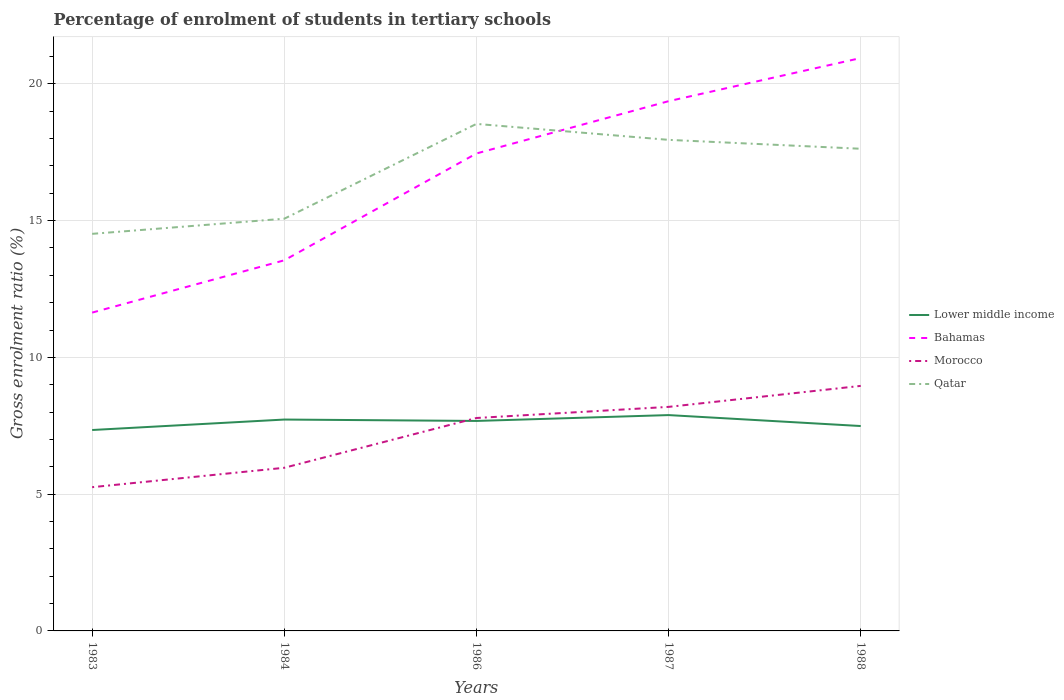How many different coloured lines are there?
Offer a very short reply. 4. Does the line corresponding to Lower middle income intersect with the line corresponding to Bahamas?
Your answer should be compact. No. Is the number of lines equal to the number of legend labels?
Ensure brevity in your answer.  Yes. Across all years, what is the maximum percentage of students enrolled in tertiary schools in Morocco?
Make the answer very short. 5.25. In which year was the percentage of students enrolled in tertiary schools in Morocco maximum?
Give a very brief answer. 1983. What is the total percentage of students enrolled in tertiary schools in Bahamas in the graph?
Your answer should be compact. -5.82. What is the difference between the highest and the second highest percentage of students enrolled in tertiary schools in Morocco?
Offer a very short reply. 3.7. What is the difference between the highest and the lowest percentage of students enrolled in tertiary schools in Lower middle income?
Keep it short and to the point. 3. Is the percentage of students enrolled in tertiary schools in Lower middle income strictly greater than the percentage of students enrolled in tertiary schools in Bahamas over the years?
Your response must be concise. Yes. How many lines are there?
Ensure brevity in your answer.  4. How many years are there in the graph?
Ensure brevity in your answer.  5. Are the values on the major ticks of Y-axis written in scientific E-notation?
Offer a terse response. No. Does the graph contain any zero values?
Offer a terse response. No. How many legend labels are there?
Your answer should be very brief. 4. What is the title of the graph?
Your response must be concise. Percentage of enrolment of students in tertiary schools. What is the label or title of the X-axis?
Keep it short and to the point. Years. What is the label or title of the Y-axis?
Give a very brief answer. Gross enrolment ratio (%). What is the Gross enrolment ratio (%) in Lower middle income in 1983?
Ensure brevity in your answer.  7.34. What is the Gross enrolment ratio (%) of Bahamas in 1983?
Provide a short and direct response. 11.64. What is the Gross enrolment ratio (%) in Morocco in 1983?
Provide a short and direct response. 5.25. What is the Gross enrolment ratio (%) of Qatar in 1983?
Make the answer very short. 14.52. What is the Gross enrolment ratio (%) of Lower middle income in 1984?
Make the answer very short. 7.73. What is the Gross enrolment ratio (%) of Bahamas in 1984?
Ensure brevity in your answer.  13.55. What is the Gross enrolment ratio (%) in Morocco in 1984?
Your answer should be very brief. 5.96. What is the Gross enrolment ratio (%) of Qatar in 1984?
Offer a very short reply. 15.07. What is the Gross enrolment ratio (%) of Lower middle income in 1986?
Your response must be concise. 7.68. What is the Gross enrolment ratio (%) in Bahamas in 1986?
Ensure brevity in your answer.  17.45. What is the Gross enrolment ratio (%) in Morocco in 1986?
Offer a very short reply. 7.78. What is the Gross enrolment ratio (%) of Qatar in 1986?
Offer a terse response. 18.53. What is the Gross enrolment ratio (%) in Lower middle income in 1987?
Make the answer very short. 7.89. What is the Gross enrolment ratio (%) of Bahamas in 1987?
Offer a terse response. 19.37. What is the Gross enrolment ratio (%) of Morocco in 1987?
Make the answer very short. 8.19. What is the Gross enrolment ratio (%) in Qatar in 1987?
Offer a very short reply. 17.95. What is the Gross enrolment ratio (%) in Lower middle income in 1988?
Provide a short and direct response. 7.49. What is the Gross enrolment ratio (%) of Bahamas in 1988?
Offer a very short reply. 20.94. What is the Gross enrolment ratio (%) in Morocco in 1988?
Your answer should be very brief. 8.96. What is the Gross enrolment ratio (%) in Qatar in 1988?
Keep it short and to the point. 17.63. Across all years, what is the maximum Gross enrolment ratio (%) in Lower middle income?
Keep it short and to the point. 7.89. Across all years, what is the maximum Gross enrolment ratio (%) of Bahamas?
Make the answer very short. 20.94. Across all years, what is the maximum Gross enrolment ratio (%) of Morocco?
Offer a terse response. 8.96. Across all years, what is the maximum Gross enrolment ratio (%) of Qatar?
Ensure brevity in your answer.  18.53. Across all years, what is the minimum Gross enrolment ratio (%) in Lower middle income?
Offer a very short reply. 7.34. Across all years, what is the minimum Gross enrolment ratio (%) in Bahamas?
Ensure brevity in your answer.  11.64. Across all years, what is the minimum Gross enrolment ratio (%) in Morocco?
Offer a very short reply. 5.25. Across all years, what is the minimum Gross enrolment ratio (%) of Qatar?
Keep it short and to the point. 14.52. What is the total Gross enrolment ratio (%) of Lower middle income in the graph?
Offer a terse response. 38.13. What is the total Gross enrolment ratio (%) in Bahamas in the graph?
Ensure brevity in your answer.  82.95. What is the total Gross enrolment ratio (%) of Morocco in the graph?
Your answer should be compact. 36.15. What is the total Gross enrolment ratio (%) of Qatar in the graph?
Keep it short and to the point. 83.7. What is the difference between the Gross enrolment ratio (%) in Lower middle income in 1983 and that in 1984?
Offer a very short reply. -0.38. What is the difference between the Gross enrolment ratio (%) of Bahamas in 1983 and that in 1984?
Provide a short and direct response. -1.91. What is the difference between the Gross enrolment ratio (%) in Morocco in 1983 and that in 1984?
Give a very brief answer. -0.71. What is the difference between the Gross enrolment ratio (%) of Qatar in 1983 and that in 1984?
Offer a very short reply. -0.55. What is the difference between the Gross enrolment ratio (%) in Lower middle income in 1983 and that in 1986?
Your answer should be compact. -0.33. What is the difference between the Gross enrolment ratio (%) in Bahamas in 1983 and that in 1986?
Offer a very short reply. -5.82. What is the difference between the Gross enrolment ratio (%) of Morocco in 1983 and that in 1986?
Provide a succinct answer. -2.53. What is the difference between the Gross enrolment ratio (%) in Qatar in 1983 and that in 1986?
Keep it short and to the point. -4.02. What is the difference between the Gross enrolment ratio (%) in Lower middle income in 1983 and that in 1987?
Provide a short and direct response. -0.55. What is the difference between the Gross enrolment ratio (%) in Bahamas in 1983 and that in 1987?
Ensure brevity in your answer.  -7.73. What is the difference between the Gross enrolment ratio (%) in Morocco in 1983 and that in 1987?
Ensure brevity in your answer.  -2.94. What is the difference between the Gross enrolment ratio (%) of Qatar in 1983 and that in 1987?
Make the answer very short. -3.44. What is the difference between the Gross enrolment ratio (%) of Lower middle income in 1983 and that in 1988?
Make the answer very short. -0.15. What is the difference between the Gross enrolment ratio (%) in Bahamas in 1983 and that in 1988?
Keep it short and to the point. -9.31. What is the difference between the Gross enrolment ratio (%) in Morocco in 1983 and that in 1988?
Keep it short and to the point. -3.7. What is the difference between the Gross enrolment ratio (%) of Qatar in 1983 and that in 1988?
Give a very brief answer. -3.11. What is the difference between the Gross enrolment ratio (%) in Lower middle income in 1984 and that in 1986?
Make the answer very short. 0.05. What is the difference between the Gross enrolment ratio (%) in Bahamas in 1984 and that in 1986?
Keep it short and to the point. -3.91. What is the difference between the Gross enrolment ratio (%) in Morocco in 1984 and that in 1986?
Provide a succinct answer. -1.82. What is the difference between the Gross enrolment ratio (%) in Qatar in 1984 and that in 1986?
Your answer should be very brief. -3.47. What is the difference between the Gross enrolment ratio (%) of Lower middle income in 1984 and that in 1987?
Make the answer very short. -0.16. What is the difference between the Gross enrolment ratio (%) of Bahamas in 1984 and that in 1987?
Ensure brevity in your answer.  -5.82. What is the difference between the Gross enrolment ratio (%) of Morocco in 1984 and that in 1987?
Offer a terse response. -2.23. What is the difference between the Gross enrolment ratio (%) in Qatar in 1984 and that in 1987?
Provide a short and direct response. -2.88. What is the difference between the Gross enrolment ratio (%) of Lower middle income in 1984 and that in 1988?
Offer a very short reply. 0.24. What is the difference between the Gross enrolment ratio (%) in Bahamas in 1984 and that in 1988?
Ensure brevity in your answer.  -7.39. What is the difference between the Gross enrolment ratio (%) of Morocco in 1984 and that in 1988?
Make the answer very short. -2.99. What is the difference between the Gross enrolment ratio (%) of Qatar in 1984 and that in 1988?
Provide a short and direct response. -2.56. What is the difference between the Gross enrolment ratio (%) in Lower middle income in 1986 and that in 1987?
Keep it short and to the point. -0.21. What is the difference between the Gross enrolment ratio (%) in Bahamas in 1986 and that in 1987?
Offer a terse response. -1.91. What is the difference between the Gross enrolment ratio (%) in Morocco in 1986 and that in 1987?
Your answer should be very brief. -0.41. What is the difference between the Gross enrolment ratio (%) in Qatar in 1986 and that in 1987?
Provide a succinct answer. 0.58. What is the difference between the Gross enrolment ratio (%) of Lower middle income in 1986 and that in 1988?
Ensure brevity in your answer.  0.19. What is the difference between the Gross enrolment ratio (%) of Bahamas in 1986 and that in 1988?
Your answer should be very brief. -3.49. What is the difference between the Gross enrolment ratio (%) of Morocco in 1986 and that in 1988?
Offer a very short reply. -1.17. What is the difference between the Gross enrolment ratio (%) of Qatar in 1986 and that in 1988?
Ensure brevity in your answer.  0.91. What is the difference between the Gross enrolment ratio (%) in Bahamas in 1987 and that in 1988?
Provide a succinct answer. -1.58. What is the difference between the Gross enrolment ratio (%) of Morocco in 1987 and that in 1988?
Offer a very short reply. -0.77. What is the difference between the Gross enrolment ratio (%) of Qatar in 1987 and that in 1988?
Make the answer very short. 0.33. What is the difference between the Gross enrolment ratio (%) of Lower middle income in 1983 and the Gross enrolment ratio (%) of Bahamas in 1984?
Your answer should be very brief. -6.2. What is the difference between the Gross enrolment ratio (%) of Lower middle income in 1983 and the Gross enrolment ratio (%) of Morocco in 1984?
Make the answer very short. 1.38. What is the difference between the Gross enrolment ratio (%) of Lower middle income in 1983 and the Gross enrolment ratio (%) of Qatar in 1984?
Make the answer very short. -7.72. What is the difference between the Gross enrolment ratio (%) in Bahamas in 1983 and the Gross enrolment ratio (%) in Morocco in 1984?
Provide a succinct answer. 5.67. What is the difference between the Gross enrolment ratio (%) of Bahamas in 1983 and the Gross enrolment ratio (%) of Qatar in 1984?
Offer a terse response. -3.43. What is the difference between the Gross enrolment ratio (%) of Morocco in 1983 and the Gross enrolment ratio (%) of Qatar in 1984?
Your response must be concise. -9.81. What is the difference between the Gross enrolment ratio (%) of Lower middle income in 1983 and the Gross enrolment ratio (%) of Bahamas in 1986?
Your answer should be compact. -10.11. What is the difference between the Gross enrolment ratio (%) in Lower middle income in 1983 and the Gross enrolment ratio (%) in Morocco in 1986?
Provide a succinct answer. -0.44. What is the difference between the Gross enrolment ratio (%) in Lower middle income in 1983 and the Gross enrolment ratio (%) in Qatar in 1986?
Give a very brief answer. -11.19. What is the difference between the Gross enrolment ratio (%) of Bahamas in 1983 and the Gross enrolment ratio (%) of Morocco in 1986?
Offer a very short reply. 3.85. What is the difference between the Gross enrolment ratio (%) in Bahamas in 1983 and the Gross enrolment ratio (%) in Qatar in 1986?
Ensure brevity in your answer.  -6.9. What is the difference between the Gross enrolment ratio (%) of Morocco in 1983 and the Gross enrolment ratio (%) of Qatar in 1986?
Make the answer very short. -13.28. What is the difference between the Gross enrolment ratio (%) in Lower middle income in 1983 and the Gross enrolment ratio (%) in Bahamas in 1987?
Your answer should be compact. -12.02. What is the difference between the Gross enrolment ratio (%) in Lower middle income in 1983 and the Gross enrolment ratio (%) in Morocco in 1987?
Ensure brevity in your answer.  -0.85. What is the difference between the Gross enrolment ratio (%) in Lower middle income in 1983 and the Gross enrolment ratio (%) in Qatar in 1987?
Provide a short and direct response. -10.61. What is the difference between the Gross enrolment ratio (%) of Bahamas in 1983 and the Gross enrolment ratio (%) of Morocco in 1987?
Offer a terse response. 3.45. What is the difference between the Gross enrolment ratio (%) of Bahamas in 1983 and the Gross enrolment ratio (%) of Qatar in 1987?
Offer a very short reply. -6.31. What is the difference between the Gross enrolment ratio (%) in Morocco in 1983 and the Gross enrolment ratio (%) in Qatar in 1987?
Your answer should be very brief. -12.7. What is the difference between the Gross enrolment ratio (%) of Lower middle income in 1983 and the Gross enrolment ratio (%) of Bahamas in 1988?
Provide a succinct answer. -13.6. What is the difference between the Gross enrolment ratio (%) in Lower middle income in 1983 and the Gross enrolment ratio (%) in Morocco in 1988?
Offer a terse response. -1.61. What is the difference between the Gross enrolment ratio (%) in Lower middle income in 1983 and the Gross enrolment ratio (%) in Qatar in 1988?
Offer a very short reply. -10.28. What is the difference between the Gross enrolment ratio (%) in Bahamas in 1983 and the Gross enrolment ratio (%) in Morocco in 1988?
Your answer should be very brief. 2.68. What is the difference between the Gross enrolment ratio (%) in Bahamas in 1983 and the Gross enrolment ratio (%) in Qatar in 1988?
Your response must be concise. -5.99. What is the difference between the Gross enrolment ratio (%) of Morocco in 1983 and the Gross enrolment ratio (%) of Qatar in 1988?
Give a very brief answer. -12.37. What is the difference between the Gross enrolment ratio (%) in Lower middle income in 1984 and the Gross enrolment ratio (%) in Bahamas in 1986?
Give a very brief answer. -9.73. What is the difference between the Gross enrolment ratio (%) of Lower middle income in 1984 and the Gross enrolment ratio (%) of Morocco in 1986?
Provide a short and direct response. -0.06. What is the difference between the Gross enrolment ratio (%) of Lower middle income in 1984 and the Gross enrolment ratio (%) of Qatar in 1986?
Provide a short and direct response. -10.81. What is the difference between the Gross enrolment ratio (%) in Bahamas in 1984 and the Gross enrolment ratio (%) in Morocco in 1986?
Offer a terse response. 5.76. What is the difference between the Gross enrolment ratio (%) of Bahamas in 1984 and the Gross enrolment ratio (%) of Qatar in 1986?
Your response must be concise. -4.99. What is the difference between the Gross enrolment ratio (%) of Morocco in 1984 and the Gross enrolment ratio (%) of Qatar in 1986?
Your response must be concise. -12.57. What is the difference between the Gross enrolment ratio (%) in Lower middle income in 1984 and the Gross enrolment ratio (%) in Bahamas in 1987?
Provide a succinct answer. -11.64. What is the difference between the Gross enrolment ratio (%) in Lower middle income in 1984 and the Gross enrolment ratio (%) in Morocco in 1987?
Provide a succinct answer. -0.46. What is the difference between the Gross enrolment ratio (%) in Lower middle income in 1984 and the Gross enrolment ratio (%) in Qatar in 1987?
Ensure brevity in your answer.  -10.22. What is the difference between the Gross enrolment ratio (%) of Bahamas in 1984 and the Gross enrolment ratio (%) of Morocco in 1987?
Offer a very short reply. 5.36. What is the difference between the Gross enrolment ratio (%) in Bahamas in 1984 and the Gross enrolment ratio (%) in Qatar in 1987?
Offer a very short reply. -4.4. What is the difference between the Gross enrolment ratio (%) of Morocco in 1984 and the Gross enrolment ratio (%) of Qatar in 1987?
Make the answer very short. -11.99. What is the difference between the Gross enrolment ratio (%) in Lower middle income in 1984 and the Gross enrolment ratio (%) in Bahamas in 1988?
Your answer should be very brief. -13.22. What is the difference between the Gross enrolment ratio (%) in Lower middle income in 1984 and the Gross enrolment ratio (%) in Morocco in 1988?
Your answer should be compact. -1.23. What is the difference between the Gross enrolment ratio (%) of Lower middle income in 1984 and the Gross enrolment ratio (%) of Qatar in 1988?
Your answer should be compact. -9.9. What is the difference between the Gross enrolment ratio (%) in Bahamas in 1984 and the Gross enrolment ratio (%) in Morocco in 1988?
Ensure brevity in your answer.  4.59. What is the difference between the Gross enrolment ratio (%) in Bahamas in 1984 and the Gross enrolment ratio (%) in Qatar in 1988?
Offer a very short reply. -4.08. What is the difference between the Gross enrolment ratio (%) of Morocco in 1984 and the Gross enrolment ratio (%) of Qatar in 1988?
Keep it short and to the point. -11.66. What is the difference between the Gross enrolment ratio (%) of Lower middle income in 1986 and the Gross enrolment ratio (%) of Bahamas in 1987?
Provide a succinct answer. -11.69. What is the difference between the Gross enrolment ratio (%) in Lower middle income in 1986 and the Gross enrolment ratio (%) in Morocco in 1987?
Offer a very short reply. -0.51. What is the difference between the Gross enrolment ratio (%) in Lower middle income in 1986 and the Gross enrolment ratio (%) in Qatar in 1987?
Give a very brief answer. -10.28. What is the difference between the Gross enrolment ratio (%) of Bahamas in 1986 and the Gross enrolment ratio (%) of Morocco in 1987?
Offer a terse response. 9.26. What is the difference between the Gross enrolment ratio (%) of Bahamas in 1986 and the Gross enrolment ratio (%) of Qatar in 1987?
Your answer should be very brief. -0.5. What is the difference between the Gross enrolment ratio (%) of Morocco in 1986 and the Gross enrolment ratio (%) of Qatar in 1987?
Your answer should be compact. -10.17. What is the difference between the Gross enrolment ratio (%) of Lower middle income in 1986 and the Gross enrolment ratio (%) of Bahamas in 1988?
Your response must be concise. -13.27. What is the difference between the Gross enrolment ratio (%) in Lower middle income in 1986 and the Gross enrolment ratio (%) in Morocco in 1988?
Offer a terse response. -1.28. What is the difference between the Gross enrolment ratio (%) in Lower middle income in 1986 and the Gross enrolment ratio (%) in Qatar in 1988?
Ensure brevity in your answer.  -9.95. What is the difference between the Gross enrolment ratio (%) in Bahamas in 1986 and the Gross enrolment ratio (%) in Morocco in 1988?
Your answer should be very brief. 8.5. What is the difference between the Gross enrolment ratio (%) in Bahamas in 1986 and the Gross enrolment ratio (%) in Qatar in 1988?
Ensure brevity in your answer.  -0.17. What is the difference between the Gross enrolment ratio (%) in Morocco in 1986 and the Gross enrolment ratio (%) in Qatar in 1988?
Provide a succinct answer. -9.84. What is the difference between the Gross enrolment ratio (%) in Lower middle income in 1987 and the Gross enrolment ratio (%) in Bahamas in 1988?
Offer a very short reply. -13.05. What is the difference between the Gross enrolment ratio (%) in Lower middle income in 1987 and the Gross enrolment ratio (%) in Morocco in 1988?
Your answer should be compact. -1.07. What is the difference between the Gross enrolment ratio (%) of Lower middle income in 1987 and the Gross enrolment ratio (%) of Qatar in 1988?
Provide a short and direct response. -9.74. What is the difference between the Gross enrolment ratio (%) in Bahamas in 1987 and the Gross enrolment ratio (%) in Morocco in 1988?
Your response must be concise. 10.41. What is the difference between the Gross enrolment ratio (%) of Bahamas in 1987 and the Gross enrolment ratio (%) of Qatar in 1988?
Offer a terse response. 1.74. What is the difference between the Gross enrolment ratio (%) of Morocco in 1987 and the Gross enrolment ratio (%) of Qatar in 1988?
Your response must be concise. -9.44. What is the average Gross enrolment ratio (%) in Lower middle income per year?
Your answer should be compact. 7.63. What is the average Gross enrolment ratio (%) of Bahamas per year?
Give a very brief answer. 16.59. What is the average Gross enrolment ratio (%) of Morocco per year?
Your response must be concise. 7.23. What is the average Gross enrolment ratio (%) of Qatar per year?
Provide a succinct answer. 16.74. In the year 1983, what is the difference between the Gross enrolment ratio (%) in Lower middle income and Gross enrolment ratio (%) in Bahamas?
Give a very brief answer. -4.29. In the year 1983, what is the difference between the Gross enrolment ratio (%) of Lower middle income and Gross enrolment ratio (%) of Morocco?
Your answer should be very brief. 2.09. In the year 1983, what is the difference between the Gross enrolment ratio (%) of Lower middle income and Gross enrolment ratio (%) of Qatar?
Offer a very short reply. -7.17. In the year 1983, what is the difference between the Gross enrolment ratio (%) in Bahamas and Gross enrolment ratio (%) in Morocco?
Your answer should be very brief. 6.38. In the year 1983, what is the difference between the Gross enrolment ratio (%) of Bahamas and Gross enrolment ratio (%) of Qatar?
Make the answer very short. -2.88. In the year 1983, what is the difference between the Gross enrolment ratio (%) of Morocco and Gross enrolment ratio (%) of Qatar?
Give a very brief answer. -9.26. In the year 1984, what is the difference between the Gross enrolment ratio (%) of Lower middle income and Gross enrolment ratio (%) of Bahamas?
Keep it short and to the point. -5.82. In the year 1984, what is the difference between the Gross enrolment ratio (%) in Lower middle income and Gross enrolment ratio (%) in Morocco?
Keep it short and to the point. 1.76. In the year 1984, what is the difference between the Gross enrolment ratio (%) in Lower middle income and Gross enrolment ratio (%) in Qatar?
Ensure brevity in your answer.  -7.34. In the year 1984, what is the difference between the Gross enrolment ratio (%) in Bahamas and Gross enrolment ratio (%) in Morocco?
Provide a short and direct response. 7.58. In the year 1984, what is the difference between the Gross enrolment ratio (%) of Bahamas and Gross enrolment ratio (%) of Qatar?
Provide a succinct answer. -1.52. In the year 1984, what is the difference between the Gross enrolment ratio (%) of Morocco and Gross enrolment ratio (%) of Qatar?
Your answer should be very brief. -9.11. In the year 1986, what is the difference between the Gross enrolment ratio (%) in Lower middle income and Gross enrolment ratio (%) in Bahamas?
Your answer should be compact. -9.78. In the year 1986, what is the difference between the Gross enrolment ratio (%) in Lower middle income and Gross enrolment ratio (%) in Morocco?
Ensure brevity in your answer.  -0.11. In the year 1986, what is the difference between the Gross enrolment ratio (%) in Lower middle income and Gross enrolment ratio (%) in Qatar?
Offer a terse response. -10.86. In the year 1986, what is the difference between the Gross enrolment ratio (%) in Bahamas and Gross enrolment ratio (%) in Morocco?
Provide a short and direct response. 9.67. In the year 1986, what is the difference between the Gross enrolment ratio (%) in Bahamas and Gross enrolment ratio (%) in Qatar?
Your response must be concise. -1.08. In the year 1986, what is the difference between the Gross enrolment ratio (%) in Morocco and Gross enrolment ratio (%) in Qatar?
Offer a very short reply. -10.75. In the year 1987, what is the difference between the Gross enrolment ratio (%) in Lower middle income and Gross enrolment ratio (%) in Bahamas?
Give a very brief answer. -11.48. In the year 1987, what is the difference between the Gross enrolment ratio (%) of Lower middle income and Gross enrolment ratio (%) of Qatar?
Make the answer very short. -10.06. In the year 1987, what is the difference between the Gross enrolment ratio (%) in Bahamas and Gross enrolment ratio (%) in Morocco?
Give a very brief answer. 11.18. In the year 1987, what is the difference between the Gross enrolment ratio (%) of Bahamas and Gross enrolment ratio (%) of Qatar?
Make the answer very short. 1.41. In the year 1987, what is the difference between the Gross enrolment ratio (%) of Morocco and Gross enrolment ratio (%) of Qatar?
Ensure brevity in your answer.  -9.76. In the year 1988, what is the difference between the Gross enrolment ratio (%) of Lower middle income and Gross enrolment ratio (%) of Bahamas?
Offer a very short reply. -13.45. In the year 1988, what is the difference between the Gross enrolment ratio (%) of Lower middle income and Gross enrolment ratio (%) of Morocco?
Provide a short and direct response. -1.47. In the year 1988, what is the difference between the Gross enrolment ratio (%) in Lower middle income and Gross enrolment ratio (%) in Qatar?
Provide a succinct answer. -10.14. In the year 1988, what is the difference between the Gross enrolment ratio (%) in Bahamas and Gross enrolment ratio (%) in Morocco?
Ensure brevity in your answer.  11.99. In the year 1988, what is the difference between the Gross enrolment ratio (%) of Bahamas and Gross enrolment ratio (%) of Qatar?
Make the answer very short. 3.32. In the year 1988, what is the difference between the Gross enrolment ratio (%) in Morocco and Gross enrolment ratio (%) in Qatar?
Your response must be concise. -8.67. What is the ratio of the Gross enrolment ratio (%) of Lower middle income in 1983 to that in 1984?
Ensure brevity in your answer.  0.95. What is the ratio of the Gross enrolment ratio (%) in Bahamas in 1983 to that in 1984?
Ensure brevity in your answer.  0.86. What is the ratio of the Gross enrolment ratio (%) of Morocco in 1983 to that in 1984?
Provide a succinct answer. 0.88. What is the ratio of the Gross enrolment ratio (%) in Qatar in 1983 to that in 1984?
Provide a short and direct response. 0.96. What is the ratio of the Gross enrolment ratio (%) of Lower middle income in 1983 to that in 1986?
Offer a terse response. 0.96. What is the ratio of the Gross enrolment ratio (%) of Bahamas in 1983 to that in 1986?
Your answer should be very brief. 0.67. What is the ratio of the Gross enrolment ratio (%) of Morocco in 1983 to that in 1986?
Keep it short and to the point. 0.68. What is the ratio of the Gross enrolment ratio (%) of Qatar in 1983 to that in 1986?
Your answer should be compact. 0.78. What is the ratio of the Gross enrolment ratio (%) of Lower middle income in 1983 to that in 1987?
Give a very brief answer. 0.93. What is the ratio of the Gross enrolment ratio (%) of Bahamas in 1983 to that in 1987?
Keep it short and to the point. 0.6. What is the ratio of the Gross enrolment ratio (%) in Morocco in 1983 to that in 1987?
Provide a succinct answer. 0.64. What is the ratio of the Gross enrolment ratio (%) of Qatar in 1983 to that in 1987?
Your answer should be very brief. 0.81. What is the ratio of the Gross enrolment ratio (%) in Lower middle income in 1983 to that in 1988?
Offer a terse response. 0.98. What is the ratio of the Gross enrolment ratio (%) of Bahamas in 1983 to that in 1988?
Make the answer very short. 0.56. What is the ratio of the Gross enrolment ratio (%) of Morocco in 1983 to that in 1988?
Provide a short and direct response. 0.59. What is the ratio of the Gross enrolment ratio (%) in Qatar in 1983 to that in 1988?
Provide a short and direct response. 0.82. What is the ratio of the Gross enrolment ratio (%) of Lower middle income in 1984 to that in 1986?
Provide a short and direct response. 1.01. What is the ratio of the Gross enrolment ratio (%) in Bahamas in 1984 to that in 1986?
Your answer should be compact. 0.78. What is the ratio of the Gross enrolment ratio (%) of Morocco in 1984 to that in 1986?
Give a very brief answer. 0.77. What is the ratio of the Gross enrolment ratio (%) of Qatar in 1984 to that in 1986?
Offer a terse response. 0.81. What is the ratio of the Gross enrolment ratio (%) in Lower middle income in 1984 to that in 1987?
Keep it short and to the point. 0.98. What is the ratio of the Gross enrolment ratio (%) in Bahamas in 1984 to that in 1987?
Your answer should be compact. 0.7. What is the ratio of the Gross enrolment ratio (%) of Morocco in 1984 to that in 1987?
Provide a succinct answer. 0.73. What is the ratio of the Gross enrolment ratio (%) of Qatar in 1984 to that in 1987?
Your answer should be compact. 0.84. What is the ratio of the Gross enrolment ratio (%) of Lower middle income in 1984 to that in 1988?
Your answer should be compact. 1.03. What is the ratio of the Gross enrolment ratio (%) in Bahamas in 1984 to that in 1988?
Your answer should be very brief. 0.65. What is the ratio of the Gross enrolment ratio (%) of Morocco in 1984 to that in 1988?
Make the answer very short. 0.67. What is the ratio of the Gross enrolment ratio (%) of Qatar in 1984 to that in 1988?
Keep it short and to the point. 0.85. What is the ratio of the Gross enrolment ratio (%) of Lower middle income in 1986 to that in 1987?
Make the answer very short. 0.97. What is the ratio of the Gross enrolment ratio (%) of Bahamas in 1986 to that in 1987?
Give a very brief answer. 0.9. What is the ratio of the Gross enrolment ratio (%) in Morocco in 1986 to that in 1987?
Provide a short and direct response. 0.95. What is the ratio of the Gross enrolment ratio (%) of Qatar in 1986 to that in 1987?
Provide a short and direct response. 1.03. What is the ratio of the Gross enrolment ratio (%) in Lower middle income in 1986 to that in 1988?
Make the answer very short. 1.02. What is the ratio of the Gross enrolment ratio (%) of Bahamas in 1986 to that in 1988?
Your answer should be very brief. 0.83. What is the ratio of the Gross enrolment ratio (%) in Morocco in 1986 to that in 1988?
Make the answer very short. 0.87. What is the ratio of the Gross enrolment ratio (%) in Qatar in 1986 to that in 1988?
Your response must be concise. 1.05. What is the ratio of the Gross enrolment ratio (%) of Lower middle income in 1987 to that in 1988?
Give a very brief answer. 1.05. What is the ratio of the Gross enrolment ratio (%) in Bahamas in 1987 to that in 1988?
Ensure brevity in your answer.  0.92. What is the ratio of the Gross enrolment ratio (%) of Morocco in 1987 to that in 1988?
Your answer should be very brief. 0.91. What is the ratio of the Gross enrolment ratio (%) in Qatar in 1987 to that in 1988?
Your answer should be very brief. 1.02. What is the difference between the highest and the second highest Gross enrolment ratio (%) of Lower middle income?
Your answer should be very brief. 0.16. What is the difference between the highest and the second highest Gross enrolment ratio (%) in Bahamas?
Provide a succinct answer. 1.58. What is the difference between the highest and the second highest Gross enrolment ratio (%) of Morocco?
Provide a short and direct response. 0.77. What is the difference between the highest and the second highest Gross enrolment ratio (%) in Qatar?
Offer a very short reply. 0.58. What is the difference between the highest and the lowest Gross enrolment ratio (%) in Lower middle income?
Your answer should be very brief. 0.55. What is the difference between the highest and the lowest Gross enrolment ratio (%) in Bahamas?
Your answer should be very brief. 9.31. What is the difference between the highest and the lowest Gross enrolment ratio (%) of Morocco?
Make the answer very short. 3.7. What is the difference between the highest and the lowest Gross enrolment ratio (%) of Qatar?
Offer a terse response. 4.02. 